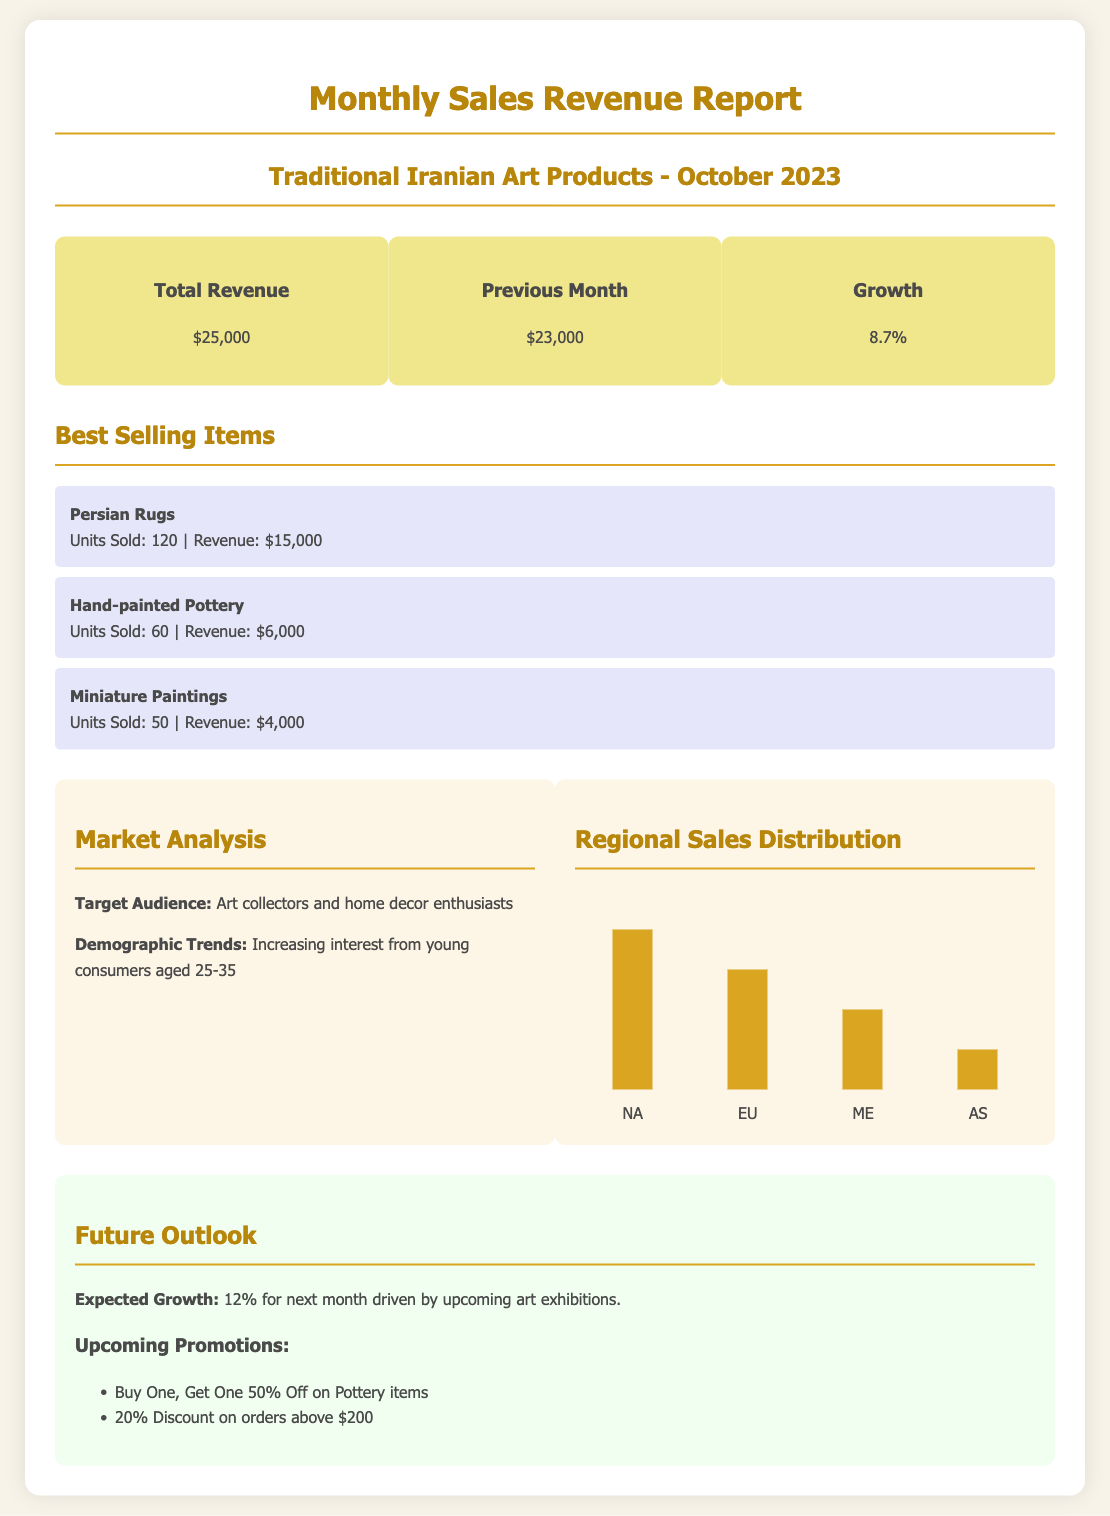what is the total revenue? The total revenue for October 2023 is listed directly in the revenue summary section of the report.
Answer: $25,000 what was the revenue for the previous month? The previous month's revenue is provided for comparison in the revenue summary section of the report.
Answer: $23,000 what is the percentage growth compared to last month? The growth percentage is explicitly mentioned in the revenue summary section, comparing current month to previous month.
Answer: 8.7% which item sold the most units? The best selling items section specifies the number of units sold for each item, identifying the one with the highest sales.
Answer: Persian Rugs how much revenue did Persian Rugs generate? The specific revenue for the best-selling item is detailed in the best sellers section of the report.
Answer: $15,000 who is the target audience for these products? The document states the target audience clearly in the market analysis section.
Answer: Art collectors and home decor enthusiasts what is the expected growth for next month? The future outlook section outlines the expected growth for the following month based on planned events.
Answer: 12% which region contributed the most to sales? The regional sales distribution chart visually represents the percentage contributions of each region, identifying the highest.
Answer: North America what discount is offered on orders above $200? The upcoming promotions section states specific incentives for future purchases, detailing the discount amount.
Answer: 20% Discount 